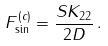<formula> <loc_0><loc_0><loc_500><loc_500>F ^ { ( c ) } _ { \sin } = \frac { S K _ { 2 2 } } { 2 D } \, .</formula> 